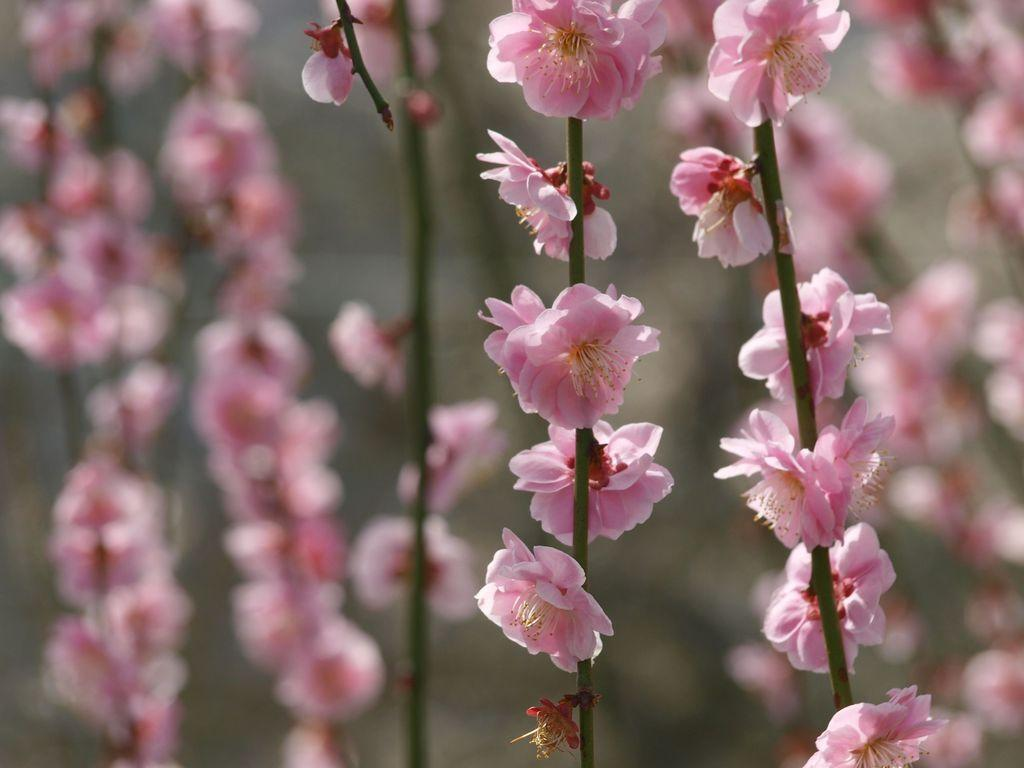What type of flowers can be seen in the image? There are pink flowers on branches in the image. Can you describe the background of the image? The background of the image is blurry. What invention is being demonstrated in the image? There is no invention being demonstrated in the image; it features pink flowers on branches and a blurry background. 